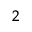Convert formula to latex. <formula><loc_0><loc_0><loc_500><loc_500>_ { 2 }</formula> 